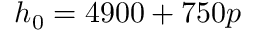<formula> <loc_0><loc_0><loc_500><loc_500>h _ { 0 } = 4 9 0 0 + 7 5 0 p</formula> 